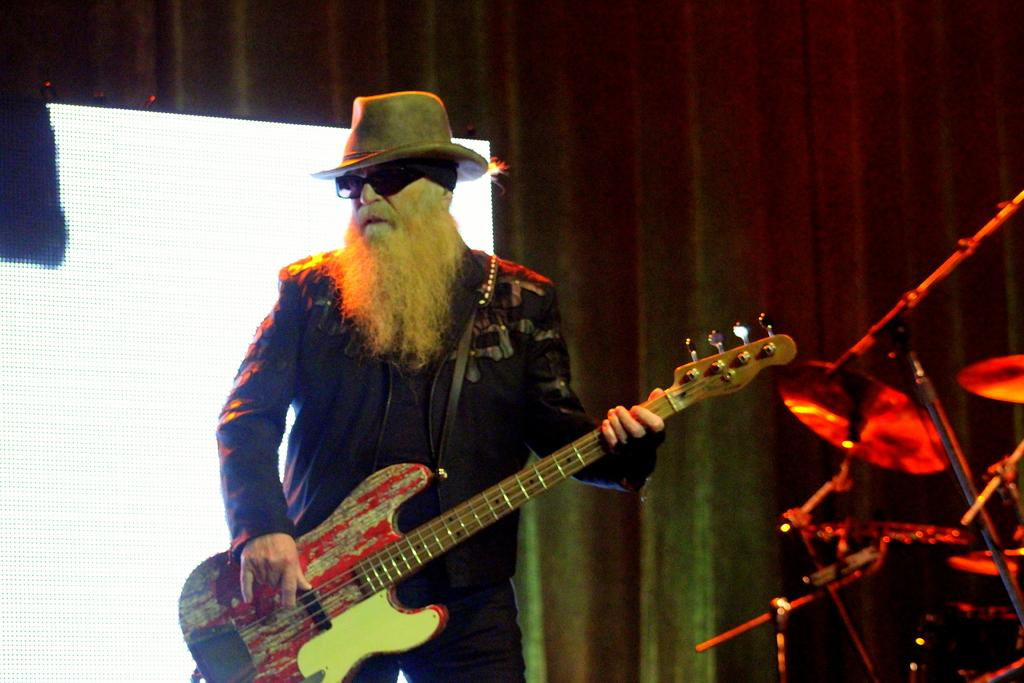Who is present in the image? There is a man in the image. What is the man holding in the image? The man is holding a guitar. Can you describe the objects on the right side of the image? There are guitars on the right side of the image. What type of punishment is the man receiving in the image? There is no indication of punishment in the image; the man is simply holding a guitar. 